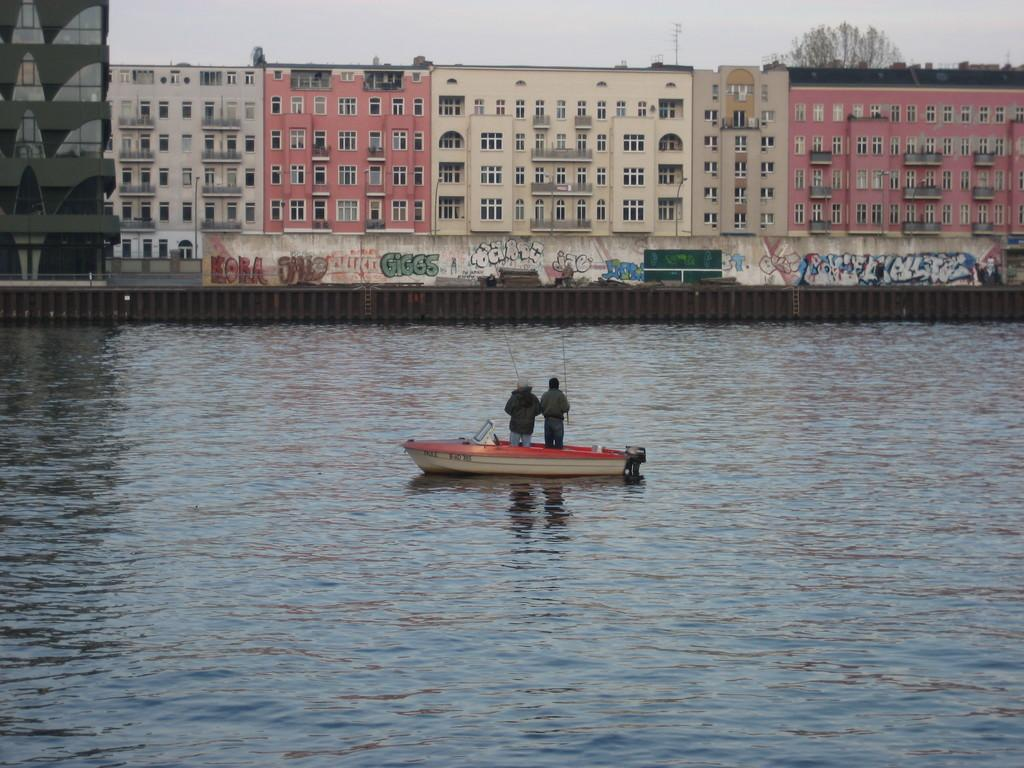How many people are in the boat in the image? There are two people in the boat in the image. What is the boat doing in the image? The boat is floating in the river. What else can be seen in the image besides the boat? There is a road, buildings, trees, and a clear sky visible in the image. What type of guitar is being played in the lunchroom in the image? There is no guitar or lunchroom present in the image. 